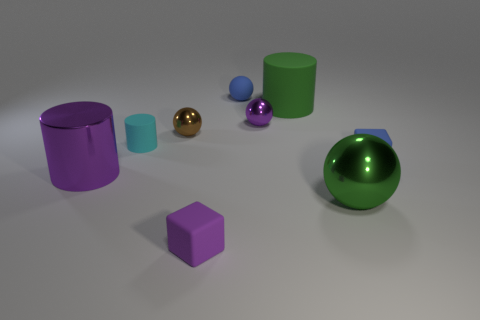Does the big rubber thing have the same color as the big metallic ball?
Provide a succinct answer. Yes. Is the color of the matte block behind the tiny purple matte cube the same as the matte sphere?
Provide a short and direct response. Yes. There is a big green object that is in front of the metal cylinder; what is its shape?
Give a very brief answer. Sphere. Are there any large matte cylinders that are to the left of the tiny blue matte thing right of the big green cylinder?
Provide a short and direct response. Yes. How many purple blocks are the same material as the big purple thing?
Provide a short and direct response. 0. There is a ball that is to the left of the blue object that is left of the big green thing that is behind the cyan matte cylinder; how big is it?
Ensure brevity in your answer.  Small. There is a large matte object; what number of brown balls are in front of it?
Your answer should be compact. 1. Is the number of shiny spheres greater than the number of tiny matte things?
Your answer should be compact. No. The sphere that is the same color as the large rubber cylinder is what size?
Offer a very short reply. Large. There is a metal thing that is both right of the big shiny cylinder and in front of the small cyan rubber cylinder; what size is it?
Make the answer very short. Large. 